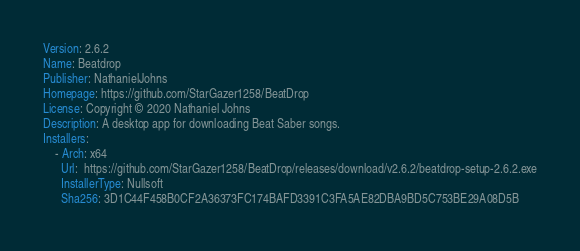Convert code to text. <code><loc_0><loc_0><loc_500><loc_500><_YAML_>Version: 2.6.2
Name: Beatdrop
Publisher: NathanielJohns
Homepage: https://github.com/StarGazer1258/BeatDrop
License: Copyright © 2020 Nathaniel Johns
Description: A desktop app for downloading Beat Saber songs.
Installers: 
    - Arch: x64
      Url:  https://github.com/StarGazer1258/BeatDrop/releases/download/v2.6.2/beatdrop-setup-2.6.2.exe
      InstallerType: Nullsoft
      Sha256: 3D1C44F458B0CF2A36373FC174BAFD3391C3FA5AE82DBA9BD5C753BE29A08D5B
</code> 